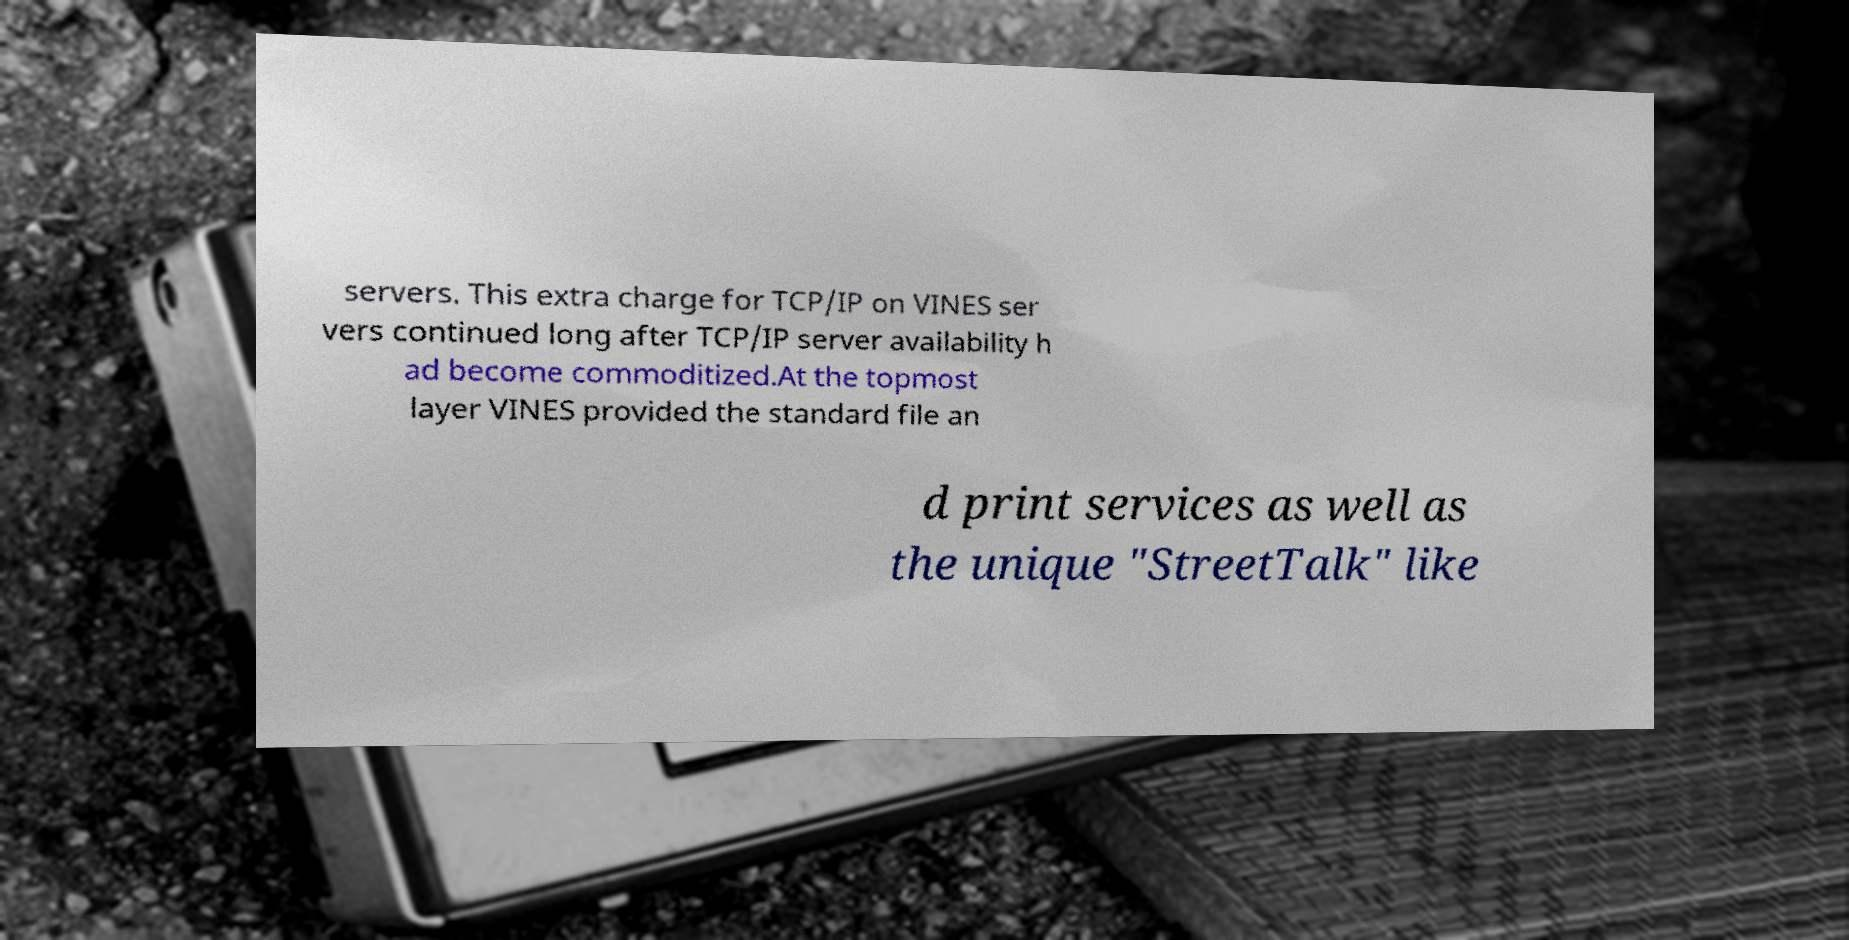Please read and relay the text visible in this image. What does it say? servers. This extra charge for TCP/IP on VINES ser vers continued long after TCP/IP server availability h ad become commoditized.At the topmost layer VINES provided the standard file an d print services as well as the unique "StreetTalk" like 